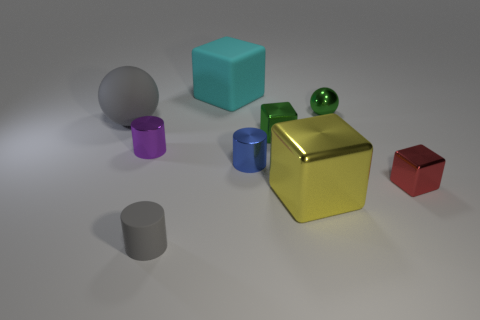Subtract all big metal cubes. How many cubes are left? 3 Subtract all green cubes. How many cubes are left? 3 Add 1 tiny purple shiny cylinders. How many objects exist? 10 Subtract all blocks. How many objects are left? 5 Subtract 1 blocks. How many blocks are left? 3 Subtract all gray blocks. How many yellow cylinders are left? 0 Subtract all small gray matte cylinders. Subtract all large yellow cubes. How many objects are left? 7 Add 9 purple metallic things. How many purple metallic things are left? 10 Add 6 cyan things. How many cyan things exist? 7 Subtract 0 red cylinders. How many objects are left? 9 